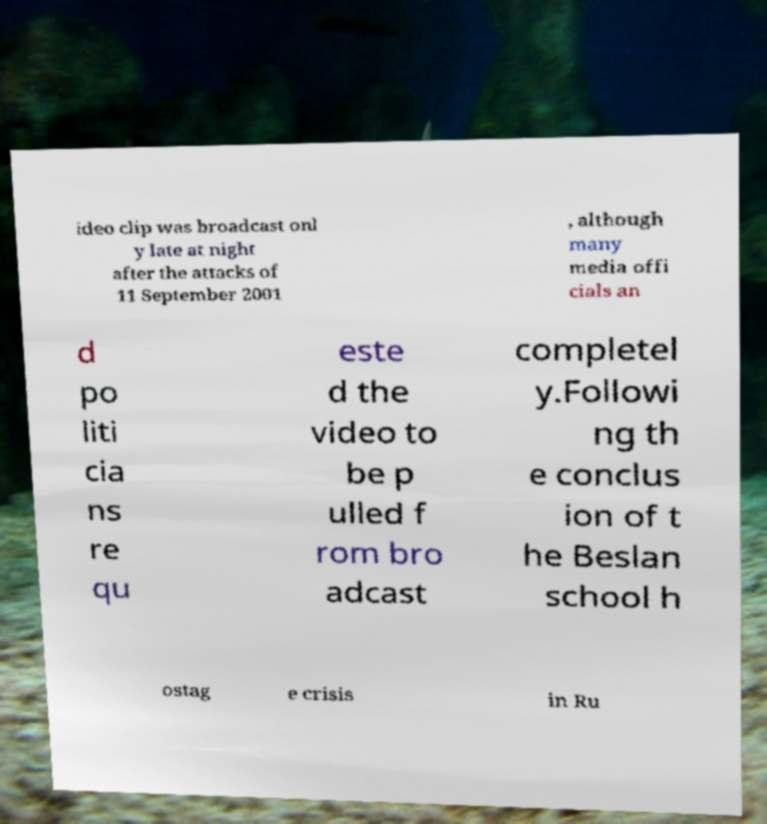For documentation purposes, I need the text within this image transcribed. Could you provide that? ideo clip was broadcast onl y late at night after the attacks of 11 September 2001 , although many media offi cials an d po liti cia ns re qu este d the video to be p ulled f rom bro adcast completel y.Followi ng th e conclus ion of t he Beslan school h ostag e crisis in Ru 